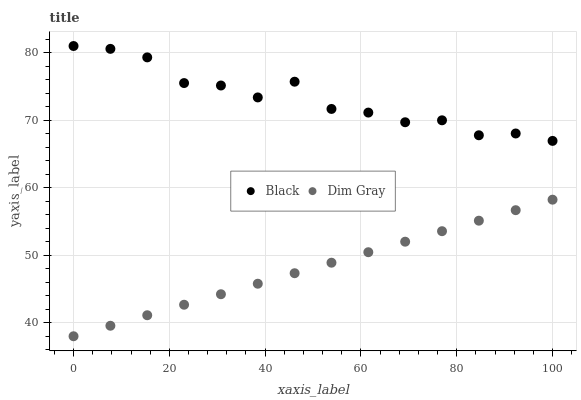Does Dim Gray have the minimum area under the curve?
Answer yes or no. Yes. Does Black have the maximum area under the curve?
Answer yes or no. Yes. Does Black have the minimum area under the curve?
Answer yes or no. No. Is Dim Gray the smoothest?
Answer yes or no. Yes. Is Black the roughest?
Answer yes or no. Yes. Is Black the smoothest?
Answer yes or no. No. Does Dim Gray have the lowest value?
Answer yes or no. Yes. Does Black have the lowest value?
Answer yes or no. No. Does Black have the highest value?
Answer yes or no. Yes. Is Dim Gray less than Black?
Answer yes or no. Yes. Is Black greater than Dim Gray?
Answer yes or no. Yes. Does Dim Gray intersect Black?
Answer yes or no. No. 